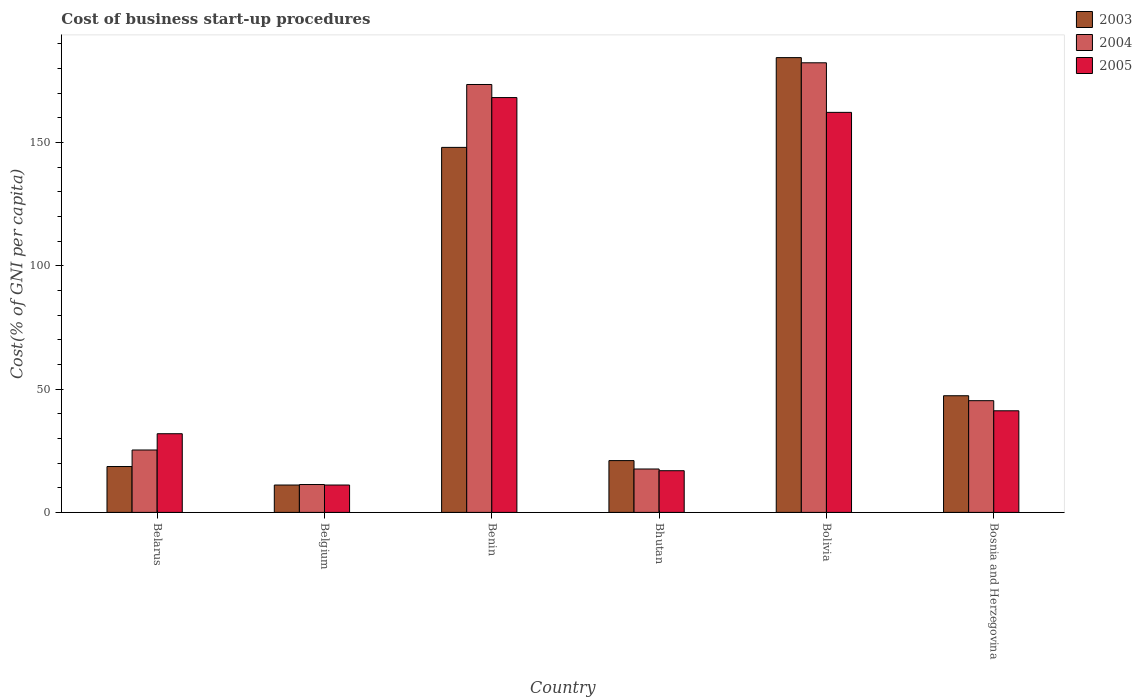How many groups of bars are there?
Your response must be concise. 6. Are the number of bars per tick equal to the number of legend labels?
Ensure brevity in your answer.  Yes. Are the number of bars on each tick of the X-axis equal?
Your response must be concise. Yes. How many bars are there on the 3rd tick from the right?
Give a very brief answer. 3. What is the label of the 6th group of bars from the left?
Keep it short and to the point. Bosnia and Herzegovina. What is the cost of business start-up procedures in 2005 in Bosnia and Herzegovina?
Offer a very short reply. 41.2. Across all countries, what is the maximum cost of business start-up procedures in 2005?
Offer a very short reply. 168.2. Across all countries, what is the minimum cost of business start-up procedures in 2004?
Your answer should be very brief. 11.3. In which country was the cost of business start-up procedures in 2004 maximum?
Make the answer very short. Bolivia. What is the total cost of business start-up procedures in 2004 in the graph?
Provide a short and direct response. 455.3. What is the difference between the cost of business start-up procedures in 2005 in Belgium and that in Bhutan?
Make the answer very short. -5.8. What is the difference between the cost of business start-up procedures in 2005 in Bhutan and the cost of business start-up procedures in 2004 in Belgium?
Your response must be concise. 5.6. What is the average cost of business start-up procedures in 2004 per country?
Offer a terse response. 75.88. What is the difference between the cost of business start-up procedures of/in 2003 and cost of business start-up procedures of/in 2004 in Bhutan?
Ensure brevity in your answer.  3.4. What is the ratio of the cost of business start-up procedures in 2004 in Belgium to that in Bolivia?
Ensure brevity in your answer.  0.06. What is the difference between the highest and the second highest cost of business start-up procedures in 2003?
Offer a very short reply. 36.4. What is the difference between the highest and the lowest cost of business start-up procedures in 2004?
Keep it short and to the point. 171. What does the 1st bar from the left in Bhutan represents?
Keep it short and to the point. 2003. Is it the case that in every country, the sum of the cost of business start-up procedures in 2003 and cost of business start-up procedures in 2005 is greater than the cost of business start-up procedures in 2004?
Your answer should be compact. Yes. How many bars are there?
Keep it short and to the point. 18. How many countries are there in the graph?
Ensure brevity in your answer.  6. Are the values on the major ticks of Y-axis written in scientific E-notation?
Keep it short and to the point. No. How many legend labels are there?
Make the answer very short. 3. What is the title of the graph?
Keep it short and to the point. Cost of business start-up procedures. Does "1974" appear as one of the legend labels in the graph?
Offer a very short reply. No. What is the label or title of the Y-axis?
Provide a short and direct response. Cost(% of GNI per capita). What is the Cost(% of GNI per capita) of 2004 in Belarus?
Ensure brevity in your answer.  25.3. What is the Cost(% of GNI per capita) of 2005 in Belarus?
Offer a very short reply. 31.9. What is the Cost(% of GNI per capita) in 2004 in Belgium?
Offer a very short reply. 11.3. What is the Cost(% of GNI per capita) in 2003 in Benin?
Offer a very short reply. 148. What is the Cost(% of GNI per capita) in 2004 in Benin?
Your answer should be compact. 173.5. What is the Cost(% of GNI per capita) in 2005 in Benin?
Your answer should be very brief. 168.2. What is the Cost(% of GNI per capita) of 2004 in Bhutan?
Ensure brevity in your answer.  17.6. What is the Cost(% of GNI per capita) of 2005 in Bhutan?
Make the answer very short. 16.9. What is the Cost(% of GNI per capita) of 2003 in Bolivia?
Offer a very short reply. 184.4. What is the Cost(% of GNI per capita) in 2004 in Bolivia?
Provide a short and direct response. 182.3. What is the Cost(% of GNI per capita) of 2005 in Bolivia?
Your response must be concise. 162.2. What is the Cost(% of GNI per capita) of 2003 in Bosnia and Herzegovina?
Your response must be concise. 47.3. What is the Cost(% of GNI per capita) in 2004 in Bosnia and Herzegovina?
Make the answer very short. 45.3. What is the Cost(% of GNI per capita) of 2005 in Bosnia and Herzegovina?
Give a very brief answer. 41.2. Across all countries, what is the maximum Cost(% of GNI per capita) of 2003?
Make the answer very short. 184.4. Across all countries, what is the maximum Cost(% of GNI per capita) in 2004?
Your answer should be very brief. 182.3. Across all countries, what is the maximum Cost(% of GNI per capita) of 2005?
Offer a very short reply. 168.2. Across all countries, what is the minimum Cost(% of GNI per capita) of 2003?
Keep it short and to the point. 11.1. Across all countries, what is the minimum Cost(% of GNI per capita) in 2005?
Give a very brief answer. 11.1. What is the total Cost(% of GNI per capita) in 2003 in the graph?
Keep it short and to the point. 430.4. What is the total Cost(% of GNI per capita) of 2004 in the graph?
Provide a short and direct response. 455.3. What is the total Cost(% of GNI per capita) of 2005 in the graph?
Ensure brevity in your answer.  431.5. What is the difference between the Cost(% of GNI per capita) of 2004 in Belarus and that in Belgium?
Your answer should be compact. 14. What is the difference between the Cost(% of GNI per capita) in 2005 in Belarus and that in Belgium?
Your response must be concise. 20.8. What is the difference between the Cost(% of GNI per capita) of 2003 in Belarus and that in Benin?
Make the answer very short. -129.4. What is the difference between the Cost(% of GNI per capita) of 2004 in Belarus and that in Benin?
Ensure brevity in your answer.  -148.2. What is the difference between the Cost(% of GNI per capita) in 2005 in Belarus and that in Benin?
Provide a succinct answer. -136.3. What is the difference between the Cost(% of GNI per capita) of 2004 in Belarus and that in Bhutan?
Make the answer very short. 7.7. What is the difference between the Cost(% of GNI per capita) in 2005 in Belarus and that in Bhutan?
Make the answer very short. 15. What is the difference between the Cost(% of GNI per capita) in 2003 in Belarus and that in Bolivia?
Your answer should be very brief. -165.8. What is the difference between the Cost(% of GNI per capita) of 2004 in Belarus and that in Bolivia?
Your answer should be compact. -157. What is the difference between the Cost(% of GNI per capita) of 2005 in Belarus and that in Bolivia?
Provide a short and direct response. -130.3. What is the difference between the Cost(% of GNI per capita) in 2003 in Belarus and that in Bosnia and Herzegovina?
Your response must be concise. -28.7. What is the difference between the Cost(% of GNI per capita) of 2004 in Belarus and that in Bosnia and Herzegovina?
Your answer should be compact. -20. What is the difference between the Cost(% of GNI per capita) in 2005 in Belarus and that in Bosnia and Herzegovina?
Offer a very short reply. -9.3. What is the difference between the Cost(% of GNI per capita) of 2003 in Belgium and that in Benin?
Your answer should be compact. -136.9. What is the difference between the Cost(% of GNI per capita) of 2004 in Belgium and that in Benin?
Your response must be concise. -162.2. What is the difference between the Cost(% of GNI per capita) in 2005 in Belgium and that in Benin?
Your answer should be very brief. -157.1. What is the difference between the Cost(% of GNI per capita) in 2003 in Belgium and that in Bhutan?
Offer a terse response. -9.9. What is the difference between the Cost(% of GNI per capita) of 2004 in Belgium and that in Bhutan?
Offer a terse response. -6.3. What is the difference between the Cost(% of GNI per capita) in 2003 in Belgium and that in Bolivia?
Your response must be concise. -173.3. What is the difference between the Cost(% of GNI per capita) in 2004 in Belgium and that in Bolivia?
Your answer should be very brief. -171. What is the difference between the Cost(% of GNI per capita) of 2005 in Belgium and that in Bolivia?
Provide a short and direct response. -151.1. What is the difference between the Cost(% of GNI per capita) in 2003 in Belgium and that in Bosnia and Herzegovina?
Ensure brevity in your answer.  -36.2. What is the difference between the Cost(% of GNI per capita) in 2004 in Belgium and that in Bosnia and Herzegovina?
Your response must be concise. -34. What is the difference between the Cost(% of GNI per capita) of 2005 in Belgium and that in Bosnia and Herzegovina?
Keep it short and to the point. -30.1. What is the difference between the Cost(% of GNI per capita) of 2003 in Benin and that in Bhutan?
Your response must be concise. 127. What is the difference between the Cost(% of GNI per capita) in 2004 in Benin and that in Bhutan?
Offer a very short reply. 155.9. What is the difference between the Cost(% of GNI per capita) in 2005 in Benin and that in Bhutan?
Your answer should be very brief. 151.3. What is the difference between the Cost(% of GNI per capita) of 2003 in Benin and that in Bolivia?
Make the answer very short. -36.4. What is the difference between the Cost(% of GNI per capita) in 2003 in Benin and that in Bosnia and Herzegovina?
Offer a very short reply. 100.7. What is the difference between the Cost(% of GNI per capita) of 2004 in Benin and that in Bosnia and Herzegovina?
Provide a short and direct response. 128.2. What is the difference between the Cost(% of GNI per capita) in 2005 in Benin and that in Bosnia and Herzegovina?
Your response must be concise. 127. What is the difference between the Cost(% of GNI per capita) of 2003 in Bhutan and that in Bolivia?
Your answer should be very brief. -163.4. What is the difference between the Cost(% of GNI per capita) of 2004 in Bhutan and that in Bolivia?
Your response must be concise. -164.7. What is the difference between the Cost(% of GNI per capita) of 2005 in Bhutan and that in Bolivia?
Ensure brevity in your answer.  -145.3. What is the difference between the Cost(% of GNI per capita) of 2003 in Bhutan and that in Bosnia and Herzegovina?
Your answer should be compact. -26.3. What is the difference between the Cost(% of GNI per capita) in 2004 in Bhutan and that in Bosnia and Herzegovina?
Provide a succinct answer. -27.7. What is the difference between the Cost(% of GNI per capita) in 2005 in Bhutan and that in Bosnia and Herzegovina?
Provide a succinct answer. -24.3. What is the difference between the Cost(% of GNI per capita) in 2003 in Bolivia and that in Bosnia and Herzegovina?
Offer a terse response. 137.1. What is the difference between the Cost(% of GNI per capita) of 2004 in Bolivia and that in Bosnia and Herzegovina?
Offer a terse response. 137. What is the difference between the Cost(% of GNI per capita) in 2005 in Bolivia and that in Bosnia and Herzegovina?
Offer a very short reply. 121. What is the difference between the Cost(% of GNI per capita) of 2003 in Belarus and the Cost(% of GNI per capita) of 2004 in Benin?
Your response must be concise. -154.9. What is the difference between the Cost(% of GNI per capita) in 2003 in Belarus and the Cost(% of GNI per capita) in 2005 in Benin?
Ensure brevity in your answer.  -149.6. What is the difference between the Cost(% of GNI per capita) in 2004 in Belarus and the Cost(% of GNI per capita) in 2005 in Benin?
Keep it short and to the point. -142.9. What is the difference between the Cost(% of GNI per capita) in 2004 in Belarus and the Cost(% of GNI per capita) in 2005 in Bhutan?
Offer a very short reply. 8.4. What is the difference between the Cost(% of GNI per capita) in 2003 in Belarus and the Cost(% of GNI per capita) in 2004 in Bolivia?
Provide a succinct answer. -163.7. What is the difference between the Cost(% of GNI per capita) of 2003 in Belarus and the Cost(% of GNI per capita) of 2005 in Bolivia?
Ensure brevity in your answer.  -143.6. What is the difference between the Cost(% of GNI per capita) in 2004 in Belarus and the Cost(% of GNI per capita) in 2005 in Bolivia?
Offer a terse response. -136.9. What is the difference between the Cost(% of GNI per capita) in 2003 in Belarus and the Cost(% of GNI per capita) in 2004 in Bosnia and Herzegovina?
Ensure brevity in your answer.  -26.7. What is the difference between the Cost(% of GNI per capita) in 2003 in Belarus and the Cost(% of GNI per capita) in 2005 in Bosnia and Herzegovina?
Give a very brief answer. -22.6. What is the difference between the Cost(% of GNI per capita) in 2004 in Belarus and the Cost(% of GNI per capita) in 2005 in Bosnia and Herzegovina?
Ensure brevity in your answer.  -15.9. What is the difference between the Cost(% of GNI per capita) in 2003 in Belgium and the Cost(% of GNI per capita) in 2004 in Benin?
Your response must be concise. -162.4. What is the difference between the Cost(% of GNI per capita) of 2003 in Belgium and the Cost(% of GNI per capita) of 2005 in Benin?
Keep it short and to the point. -157.1. What is the difference between the Cost(% of GNI per capita) of 2004 in Belgium and the Cost(% of GNI per capita) of 2005 in Benin?
Give a very brief answer. -156.9. What is the difference between the Cost(% of GNI per capita) in 2003 in Belgium and the Cost(% of GNI per capita) in 2004 in Bhutan?
Your answer should be very brief. -6.5. What is the difference between the Cost(% of GNI per capita) of 2004 in Belgium and the Cost(% of GNI per capita) of 2005 in Bhutan?
Keep it short and to the point. -5.6. What is the difference between the Cost(% of GNI per capita) in 2003 in Belgium and the Cost(% of GNI per capita) in 2004 in Bolivia?
Offer a terse response. -171.2. What is the difference between the Cost(% of GNI per capita) of 2003 in Belgium and the Cost(% of GNI per capita) of 2005 in Bolivia?
Your answer should be very brief. -151.1. What is the difference between the Cost(% of GNI per capita) in 2004 in Belgium and the Cost(% of GNI per capita) in 2005 in Bolivia?
Give a very brief answer. -150.9. What is the difference between the Cost(% of GNI per capita) in 2003 in Belgium and the Cost(% of GNI per capita) in 2004 in Bosnia and Herzegovina?
Your response must be concise. -34.2. What is the difference between the Cost(% of GNI per capita) of 2003 in Belgium and the Cost(% of GNI per capita) of 2005 in Bosnia and Herzegovina?
Offer a very short reply. -30.1. What is the difference between the Cost(% of GNI per capita) of 2004 in Belgium and the Cost(% of GNI per capita) of 2005 in Bosnia and Herzegovina?
Offer a terse response. -29.9. What is the difference between the Cost(% of GNI per capita) in 2003 in Benin and the Cost(% of GNI per capita) in 2004 in Bhutan?
Your answer should be compact. 130.4. What is the difference between the Cost(% of GNI per capita) in 2003 in Benin and the Cost(% of GNI per capita) in 2005 in Bhutan?
Keep it short and to the point. 131.1. What is the difference between the Cost(% of GNI per capita) in 2004 in Benin and the Cost(% of GNI per capita) in 2005 in Bhutan?
Your answer should be compact. 156.6. What is the difference between the Cost(% of GNI per capita) in 2003 in Benin and the Cost(% of GNI per capita) in 2004 in Bolivia?
Make the answer very short. -34.3. What is the difference between the Cost(% of GNI per capita) in 2003 in Benin and the Cost(% of GNI per capita) in 2005 in Bolivia?
Your answer should be compact. -14.2. What is the difference between the Cost(% of GNI per capita) in 2004 in Benin and the Cost(% of GNI per capita) in 2005 in Bolivia?
Offer a terse response. 11.3. What is the difference between the Cost(% of GNI per capita) in 2003 in Benin and the Cost(% of GNI per capita) in 2004 in Bosnia and Herzegovina?
Ensure brevity in your answer.  102.7. What is the difference between the Cost(% of GNI per capita) in 2003 in Benin and the Cost(% of GNI per capita) in 2005 in Bosnia and Herzegovina?
Keep it short and to the point. 106.8. What is the difference between the Cost(% of GNI per capita) in 2004 in Benin and the Cost(% of GNI per capita) in 2005 in Bosnia and Herzegovina?
Provide a short and direct response. 132.3. What is the difference between the Cost(% of GNI per capita) of 2003 in Bhutan and the Cost(% of GNI per capita) of 2004 in Bolivia?
Your answer should be very brief. -161.3. What is the difference between the Cost(% of GNI per capita) of 2003 in Bhutan and the Cost(% of GNI per capita) of 2005 in Bolivia?
Keep it short and to the point. -141.2. What is the difference between the Cost(% of GNI per capita) of 2004 in Bhutan and the Cost(% of GNI per capita) of 2005 in Bolivia?
Offer a terse response. -144.6. What is the difference between the Cost(% of GNI per capita) in 2003 in Bhutan and the Cost(% of GNI per capita) in 2004 in Bosnia and Herzegovina?
Provide a succinct answer. -24.3. What is the difference between the Cost(% of GNI per capita) of 2003 in Bhutan and the Cost(% of GNI per capita) of 2005 in Bosnia and Herzegovina?
Your answer should be very brief. -20.2. What is the difference between the Cost(% of GNI per capita) in 2004 in Bhutan and the Cost(% of GNI per capita) in 2005 in Bosnia and Herzegovina?
Offer a very short reply. -23.6. What is the difference between the Cost(% of GNI per capita) in 2003 in Bolivia and the Cost(% of GNI per capita) in 2004 in Bosnia and Herzegovina?
Provide a succinct answer. 139.1. What is the difference between the Cost(% of GNI per capita) in 2003 in Bolivia and the Cost(% of GNI per capita) in 2005 in Bosnia and Herzegovina?
Offer a very short reply. 143.2. What is the difference between the Cost(% of GNI per capita) in 2004 in Bolivia and the Cost(% of GNI per capita) in 2005 in Bosnia and Herzegovina?
Offer a very short reply. 141.1. What is the average Cost(% of GNI per capita) of 2003 per country?
Ensure brevity in your answer.  71.73. What is the average Cost(% of GNI per capita) in 2004 per country?
Ensure brevity in your answer.  75.88. What is the average Cost(% of GNI per capita) of 2005 per country?
Your answer should be compact. 71.92. What is the difference between the Cost(% of GNI per capita) of 2003 and Cost(% of GNI per capita) of 2004 in Belarus?
Your response must be concise. -6.7. What is the difference between the Cost(% of GNI per capita) in 2003 and Cost(% of GNI per capita) in 2005 in Belarus?
Provide a short and direct response. -13.3. What is the difference between the Cost(% of GNI per capita) of 2004 and Cost(% of GNI per capita) of 2005 in Belarus?
Provide a succinct answer. -6.6. What is the difference between the Cost(% of GNI per capita) in 2003 and Cost(% of GNI per capita) in 2004 in Belgium?
Your answer should be very brief. -0.2. What is the difference between the Cost(% of GNI per capita) in 2004 and Cost(% of GNI per capita) in 2005 in Belgium?
Give a very brief answer. 0.2. What is the difference between the Cost(% of GNI per capita) of 2003 and Cost(% of GNI per capita) of 2004 in Benin?
Keep it short and to the point. -25.5. What is the difference between the Cost(% of GNI per capita) in 2003 and Cost(% of GNI per capita) in 2005 in Benin?
Ensure brevity in your answer.  -20.2. What is the difference between the Cost(% of GNI per capita) of 2004 and Cost(% of GNI per capita) of 2005 in Benin?
Keep it short and to the point. 5.3. What is the difference between the Cost(% of GNI per capita) in 2003 and Cost(% of GNI per capita) in 2004 in Bhutan?
Ensure brevity in your answer.  3.4. What is the difference between the Cost(% of GNI per capita) of 2003 and Cost(% of GNI per capita) of 2005 in Bhutan?
Your response must be concise. 4.1. What is the difference between the Cost(% of GNI per capita) of 2003 and Cost(% of GNI per capita) of 2004 in Bolivia?
Your answer should be very brief. 2.1. What is the difference between the Cost(% of GNI per capita) of 2003 and Cost(% of GNI per capita) of 2005 in Bolivia?
Your answer should be compact. 22.2. What is the difference between the Cost(% of GNI per capita) of 2004 and Cost(% of GNI per capita) of 2005 in Bolivia?
Offer a very short reply. 20.1. What is the difference between the Cost(% of GNI per capita) of 2003 and Cost(% of GNI per capita) of 2005 in Bosnia and Herzegovina?
Provide a short and direct response. 6.1. What is the difference between the Cost(% of GNI per capita) of 2004 and Cost(% of GNI per capita) of 2005 in Bosnia and Herzegovina?
Make the answer very short. 4.1. What is the ratio of the Cost(% of GNI per capita) in 2003 in Belarus to that in Belgium?
Ensure brevity in your answer.  1.68. What is the ratio of the Cost(% of GNI per capita) in 2004 in Belarus to that in Belgium?
Give a very brief answer. 2.24. What is the ratio of the Cost(% of GNI per capita) in 2005 in Belarus to that in Belgium?
Offer a very short reply. 2.87. What is the ratio of the Cost(% of GNI per capita) of 2003 in Belarus to that in Benin?
Give a very brief answer. 0.13. What is the ratio of the Cost(% of GNI per capita) in 2004 in Belarus to that in Benin?
Provide a succinct answer. 0.15. What is the ratio of the Cost(% of GNI per capita) of 2005 in Belarus to that in Benin?
Ensure brevity in your answer.  0.19. What is the ratio of the Cost(% of GNI per capita) of 2003 in Belarus to that in Bhutan?
Offer a very short reply. 0.89. What is the ratio of the Cost(% of GNI per capita) in 2004 in Belarus to that in Bhutan?
Provide a succinct answer. 1.44. What is the ratio of the Cost(% of GNI per capita) in 2005 in Belarus to that in Bhutan?
Keep it short and to the point. 1.89. What is the ratio of the Cost(% of GNI per capita) of 2003 in Belarus to that in Bolivia?
Your response must be concise. 0.1. What is the ratio of the Cost(% of GNI per capita) of 2004 in Belarus to that in Bolivia?
Offer a very short reply. 0.14. What is the ratio of the Cost(% of GNI per capita) in 2005 in Belarus to that in Bolivia?
Provide a short and direct response. 0.2. What is the ratio of the Cost(% of GNI per capita) of 2003 in Belarus to that in Bosnia and Herzegovina?
Ensure brevity in your answer.  0.39. What is the ratio of the Cost(% of GNI per capita) in 2004 in Belarus to that in Bosnia and Herzegovina?
Ensure brevity in your answer.  0.56. What is the ratio of the Cost(% of GNI per capita) in 2005 in Belarus to that in Bosnia and Herzegovina?
Offer a very short reply. 0.77. What is the ratio of the Cost(% of GNI per capita) in 2003 in Belgium to that in Benin?
Offer a very short reply. 0.07. What is the ratio of the Cost(% of GNI per capita) in 2004 in Belgium to that in Benin?
Offer a very short reply. 0.07. What is the ratio of the Cost(% of GNI per capita) in 2005 in Belgium to that in Benin?
Offer a terse response. 0.07. What is the ratio of the Cost(% of GNI per capita) in 2003 in Belgium to that in Bhutan?
Offer a very short reply. 0.53. What is the ratio of the Cost(% of GNI per capita) in 2004 in Belgium to that in Bhutan?
Provide a succinct answer. 0.64. What is the ratio of the Cost(% of GNI per capita) in 2005 in Belgium to that in Bhutan?
Provide a short and direct response. 0.66. What is the ratio of the Cost(% of GNI per capita) of 2003 in Belgium to that in Bolivia?
Keep it short and to the point. 0.06. What is the ratio of the Cost(% of GNI per capita) in 2004 in Belgium to that in Bolivia?
Make the answer very short. 0.06. What is the ratio of the Cost(% of GNI per capita) in 2005 in Belgium to that in Bolivia?
Keep it short and to the point. 0.07. What is the ratio of the Cost(% of GNI per capita) in 2003 in Belgium to that in Bosnia and Herzegovina?
Offer a terse response. 0.23. What is the ratio of the Cost(% of GNI per capita) of 2004 in Belgium to that in Bosnia and Herzegovina?
Provide a succinct answer. 0.25. What is the ratio of the Cost(% of GNI per capita) of 2005 in Belgium to that in Bosnia and Herzegovina?
Offer a terse response. 0.27. What is the ratio of the Cost(% of GNI per capita) of 2003 in Benin to that in Bhutan?
Provide a short and direct response. 7.05. What is the ratio of the Cost(% of GNI per capita) in 2004 in Benin to that in Bhutan?
Provide a short and direct response. 9.86. What is the ratio of the Cost(% of GNI per capita) in 2005 in Benin to that in Bhutan?
Give a very brief answer. 9.95. What is the ratio of the Cost(% of GNI per capita) in 2003 in Benin to that in Bolivia?
Keep it short and to the point. 0.8. What is the ratio of the Cost(% of GNI per capita) in 2004 in Benin to that in Bolivia?
Your response must be concise. 0.95. What is the ratio of the Cost(% of GNI per capita) in 2003 in Benin to that in Bosnia and Herzegovina?
Provide a short and direct response. 3.13. What is the ratio of the Cost(% of GNI per capita) in 2004 in Benin to that in Bosnia and Herzegovina?
Offer a terse response. 3.83. What is the ratio of the Cost(% of GNI per capita) in 2005 in Benin to that in Bosnia and Herzegovina?
Give a very brief answer. 4.08. What is the ratio of the Cost(% of GNI per capita) of 2003 in Bhutan to that in Bolivia?
Keep it short and to the point. 0.11. What is the ratio of the Cost(% of GNI per capita) of 2004 in Bhutan to that in Bolivia?
Make the answer very short. 0.1. What is the ratio of the Cost(% of GNI per capita) of 2005 in Bhutan to that in Bolivia?
Ensure brevity in your answer.  0.1. What is the ratio of the Cost(% of GNI per capita) of 2003 in Bhutan to that in Bosnia and Herzegovina?
Your answer should be compact. 0.44. What is the ratio of the Cost(% of GNI per capita) in 2004 in Bhutan to that in Bosnia and Herzegovina?
Provide a short and direct response. 0.39. What is the ratio of the Cost(% of GNI per capita) in 2005 in Bhutan to that in Bosnia and Herzegovina?
Keep it short and to the point. 0.41. What is the ratio of the Cost(% of GNI per capita) in 2003 in Bolivia to that in Bosnia and Herzegovina?
Your answer should be compact. 3.9. What is the ratio of the Cost(% of GNI per capita) of 2004 in Bolivia to that in Bosnia and Herzegovina?
Give a very brief answer. 4.02. What is the ratio of the Cost(% of GNI per capita) in 2005 in Bolivia to that in Bosnia and Herzegovina?
Offer a very short reply. 3.94. What is the difference between the highest and the second highest Cost(% of GNI per capita) in 2003?
Offer a very short reply. 36.4. What is the difference between the highest and the second highest Cost(% of GNI per capita) in 2005?
Your answer should be compact. 6. What is the difference between the highest and the lowest Cost(% of GNI per capita) of 2003?
Keep it short and to the point. 173.3. What is the difference between the highest and the lowest Cost(% of GNI per capita) of 2004?
Your answer should be very brief. 171. What is the difference between the highest and the lowest Cost(% of GNI per capita) in 2005?
Provide a short and direct response. 157.1. 